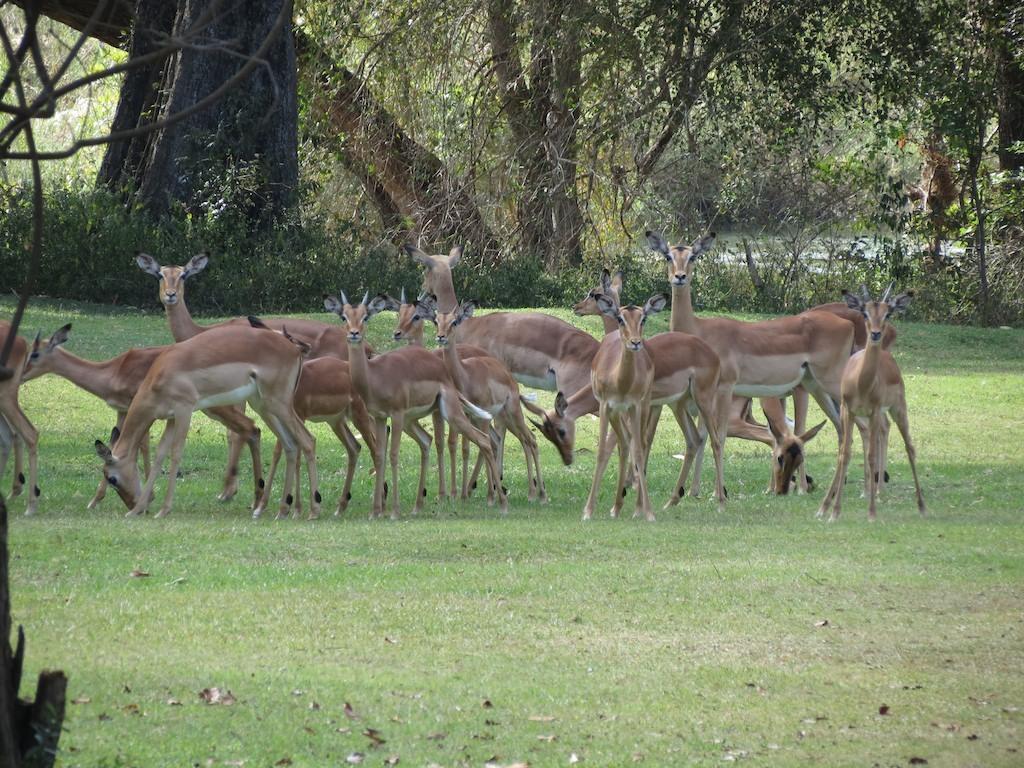Can you describe this image briefly? In this image we can see so many trees, plants, bushes, grass and some leaves on the ground. So many animals on the ground. 